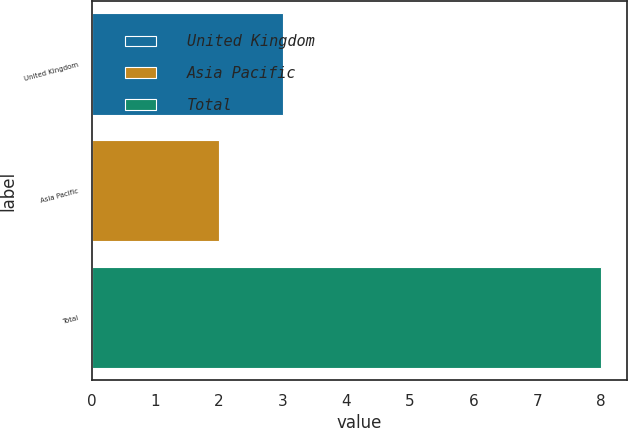<chart> <loc_0><loc_0><loc_500><loc_500><bar_chart><fcel>United Kingdom<fcel>Asia Pacific<fcel>Total<nl><fcel>3<fcel>2<fcel>8<nl></chart> 